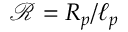<formula> <loc_0><loc_0><loc_500><loc_500>\mathcal { R } = R _ { p } / \ell _ { p }</formula> 